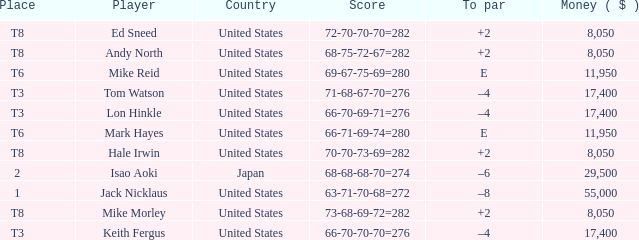What player has money larger than 11,950 and is placed in t8 and has the score of 73-68-69-72=282? None. 